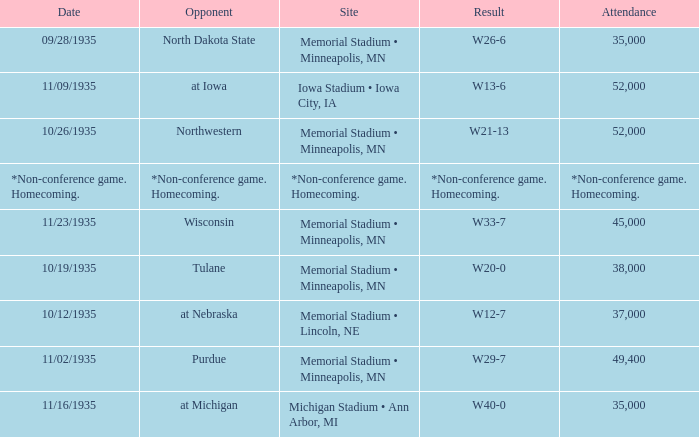How many spectators attended the game on 11/09/1935? 52000.0. 